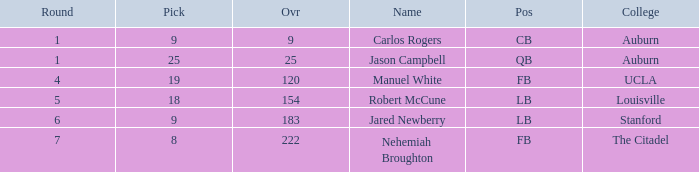Which college had an overall pick of 9? Auburn. 